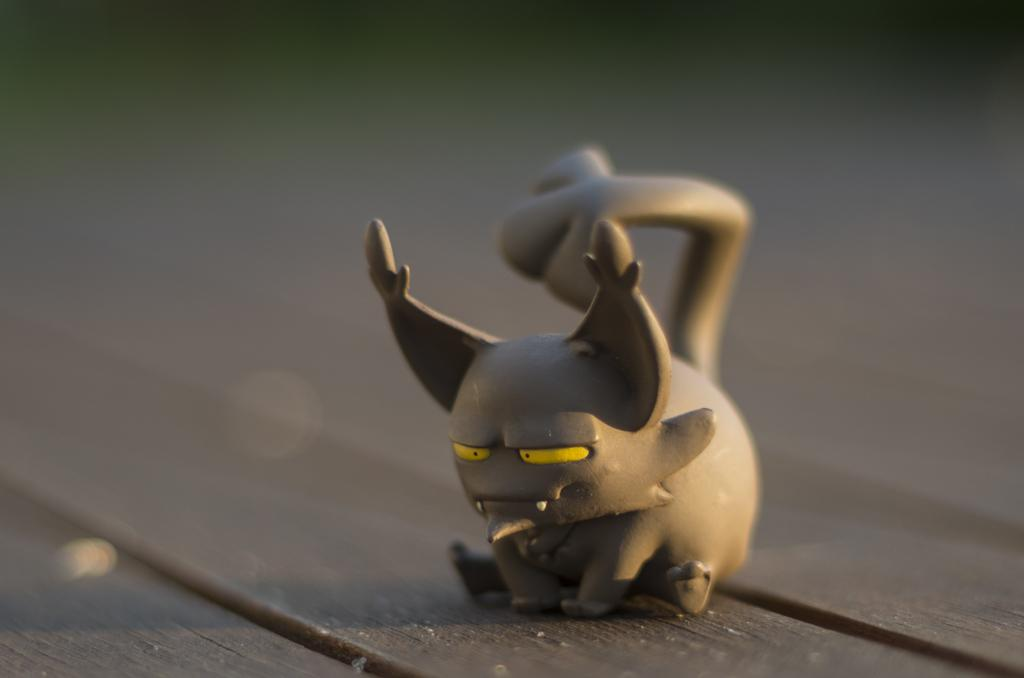What object can be seen in the image? There is a toy in the image. What color is the toy? The toy is gray in color. On what surface is the toy placed? The toy is on a wooden surface. How would you describe the background of the image? The background of the image is blurred. What type of disease is affecting the zebra in the image? There is no zebra present in the image, so it is not possible to determine if a disease is affecting it. 